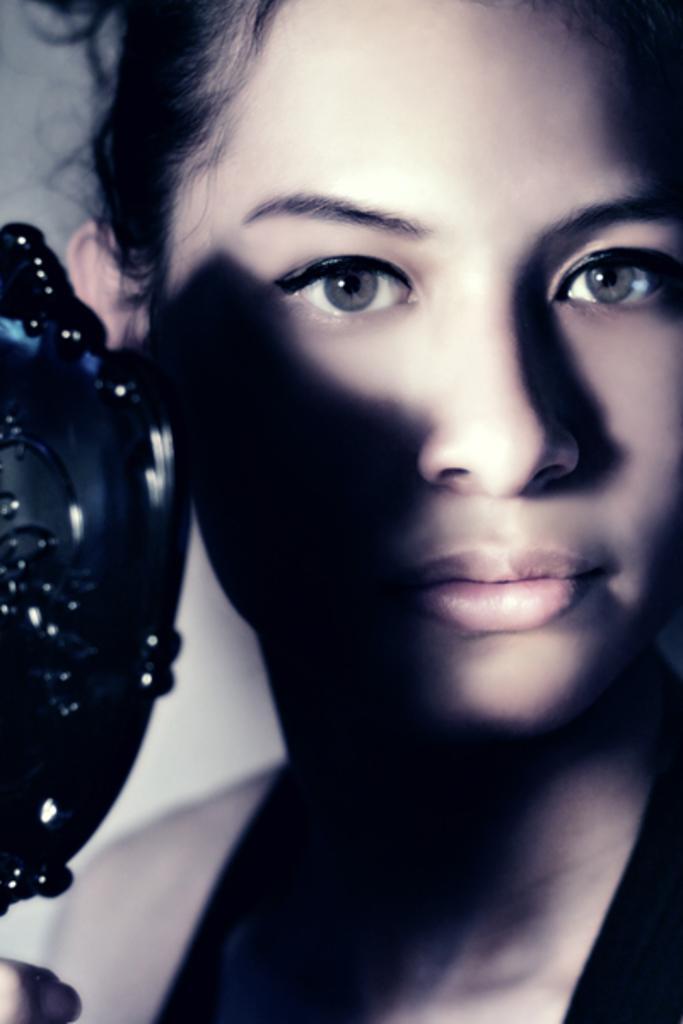Could you give a brief overview of what you see in this image? In this image I can see a person face and the black color object in front. 